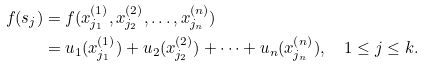<formula> <loc_0><loc_0><loc_500><loc_500>f ( s _ { j } ) & = f ( x _ { j _ { 1 } } ^ { ( 1 ) } , x _ { j _ { 2 } } ^ { ( 2 ) } , \dots , x _ { j _ { n } } ^ { ( n ) } ) \\ & = u _ { 1 } ( x _ { j _ { 1 } } ^ { ( 1 ) } ) + u _ { 2 } ( x _ { j _ { 2 } } ^ { ( 2 ) } ) + \cdots + u _ { n } ( x _ { j _ { n } } ^ { ( n ) } ) , \quad 1 \leq j \leq k .</formula> 